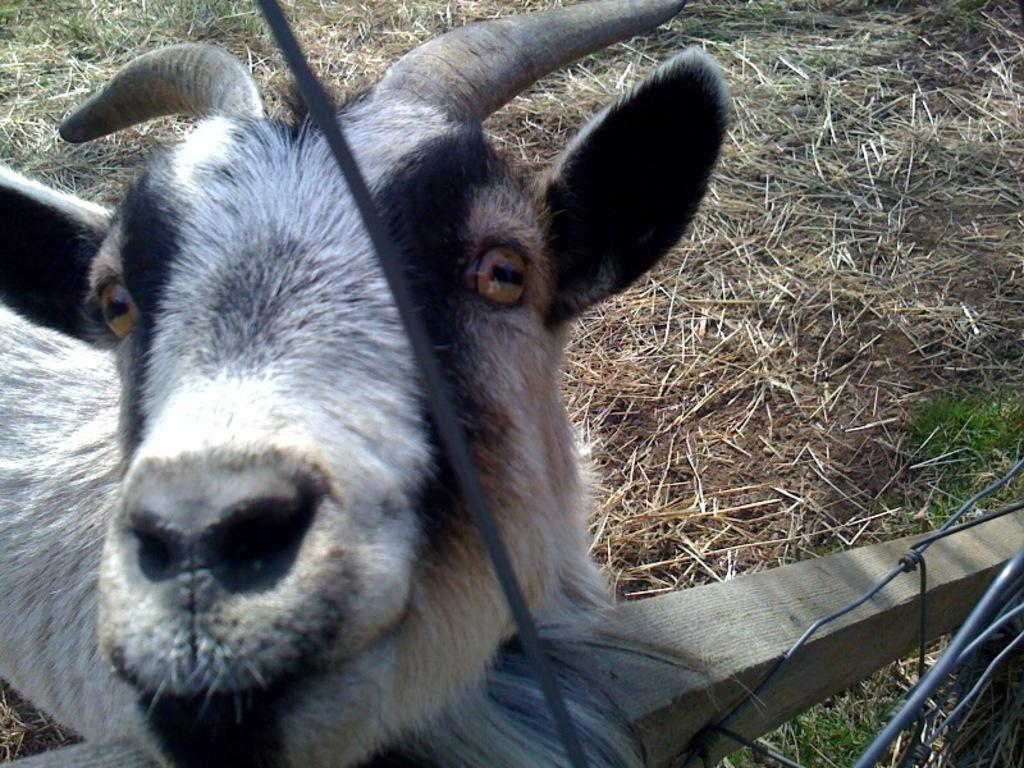What type of living creature is in the image? There is an animal in the image. What is located at the bottom of the image? There is a fence at the bottom of the image. What type of vegetation can be seen in the background of the image? There is grass in the background of the image. How does the animal show respect to the fence in the image? The animal does not show respect to the fence in the image, as the concept of respect is not applicable to animals in this context. 